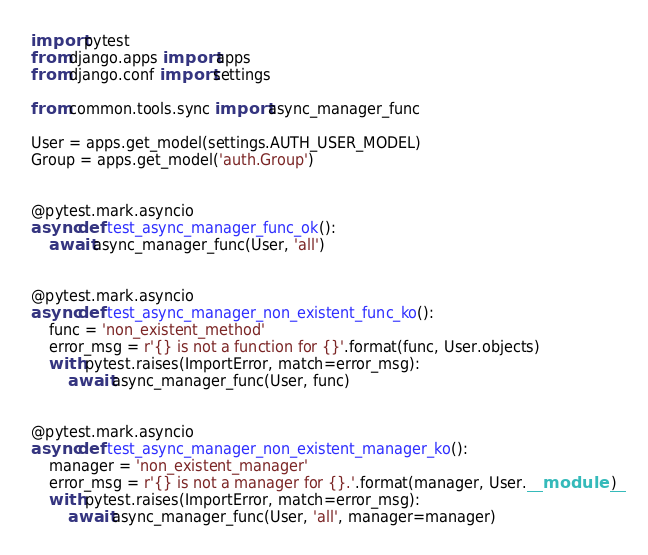<code> <loc_0><loc_0><loc_500><loc_500><_Python_>import pytest
from django.apps import apps
from django.conf import settings

from common.tools.sync import async_manager_func

User = apps.get_model(settings.AUTH_USER_MODEL)
Group = apps.get_model('auth.Group')


@pytest.mark.asyncio
async def test_async_manager_func_ok():
    await async_manager_func(User, 'all')


@pytest.mark.asyncio
async def test_async_manager_non_existent_func_ko():
    func = 'non_existent_method'
    error_msg = r'{} is not a function for {}'.format(func, User.objects)
    with pytest.raises(ImportError, match=error_msg):
        await async_manager_func(User, func)


@pytest.mark.asyncio
async def test_async_manager_non_existent_manager_ko():
    manager = 'non_existent_manager'
    error_msg = r'{} is not a manager for {}.'.format(manager, User.__module__)
    with pytest.raises(ImportError, match=error_msg):
        await async_manager_func(User, 'all', manager=manager)
</code> 